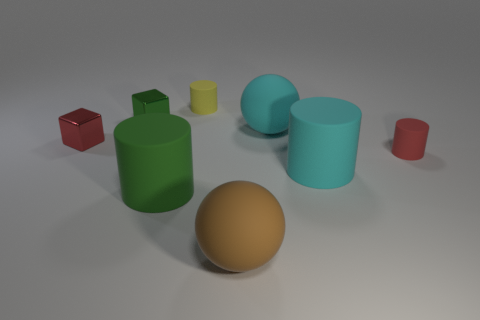Is there anything else that is the same shape as the big green rubber thing?
Your answer should be compact. Yes. There is a large matte object that is in front of the green cylinder in front of the small red rubber object; what number of large brown objects are on the left side of it?
Keep it short and to the point. 0. There is a cyan rubber sphere; what number of large green cylinders are to the left of it?
Give a very brief answer. 1. How many other red blocks are the same material as the tiny red block?
Keep it short and to the point. 0. What is the color of the other big cylinder that is made of the same material as the large green cylinder?
Give a very brief answer. Cyan. There is a tiny red thing that is left of the tiny cylinder that is on the right side of the ball that is in front of the red cylinder; what is it made of?
Your response must be concise. Metal. There is a red thing on the left side of the green cube; does it have the same size as the brown ball?
Offer a very short reply. No. What number of tiny objects are either brown rubber spheres or metallic blocks?
Your response must be concise. 2. There is a red matte object that is the same size as the red metallic block; what is its shape?
Keep it short and to the point. Cylinder. What number of things are either large cyan rubber objects in front of the small red rubber object or tiny rubber things?
Offer a very short reply. 3. 